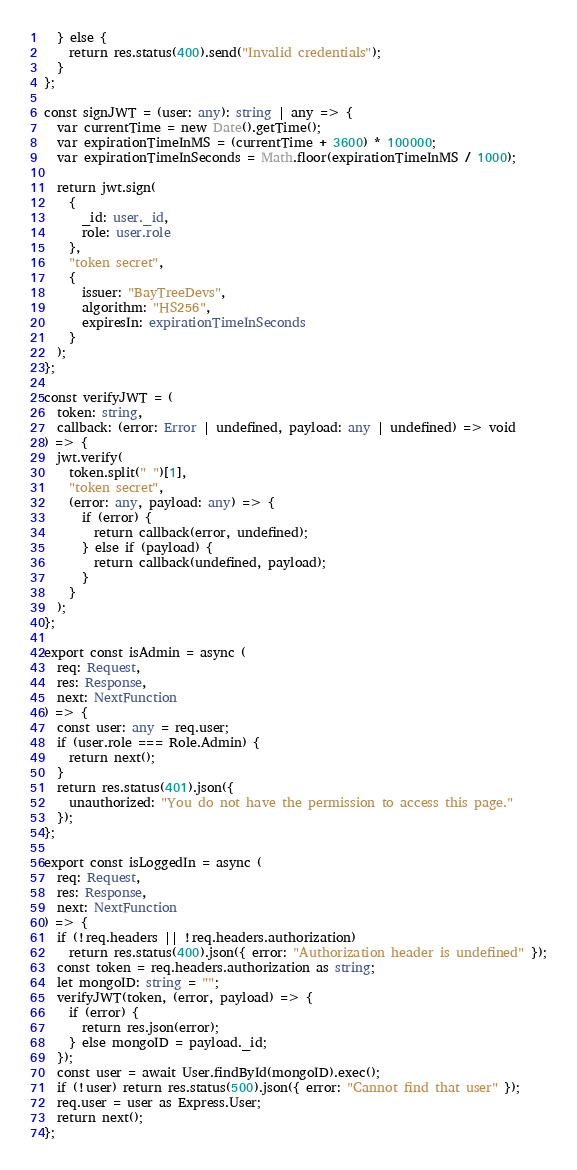Convert code to text. <code><loc_0><loc_0><loc_500><loc_500><_TypeScript_>  } else {
    return res.status(400).send("Invalid credentials");
  }
};

const signJWT = (user: any): string | any => {
  var currentTime = new Date().getTime();
  var expirationTimeInMS = (currentTime + 3600) * 100000;
  var expirationTimeInSeconds = Math.floor(expirationTimeInMS / 1000);

  return jwt.sign(
    {
      _id: user._id,
      role: user.role
    },
    "token secret",
    {
      issuer: "BayTreeDevs",
      algorithm: "HS256",
      expiresIn: expirationTimeInSeconds
    }
  );
};

const verifyJWT = (
  token: string,
  callback: (error: Error | undefined, payload: any | undefined) => void
) => {
  jwt.verify(
    token.split(" ")[1],
    "token secret",
    (error: any, payload: any) => {
      if (error) {
        return callback(error, undefined);
      } else if (payload) {
        return callback(undefined, payload);
      }
    }
  );
};

export const isAdmin = async (
  req: Request,
  res: Response,
  next: NextFunction
) => {
  const user: any = req.user;
  if (user.role === Role.Admin) {
    return next();
  }
  return res.status(401).json({
    unauthorized: "You do not have the permission to access this page."
  });
};

export const isLoggedIn = async (
  req: Request,
  res: Response,
  next: NextFunction
) => {
  if (!req.headers || !req.headers.authorization)
    return res.status(400).json({ error: "Authorization header is undefined" });
  const token = req.headers.authorization as string;
  let mongoID: string = "";
  verifyJWT(token, (error, payload) => {
    if (error) {
      return res.json(error);
    } else mongoID = payload._id;
  });
  const user = await User.findById(mongoID).exec();
  if (!user) return res.status(500).json({ error: "Cannot find that user" });
  req.user = user as Express.User;
  return next();
};
</code> 